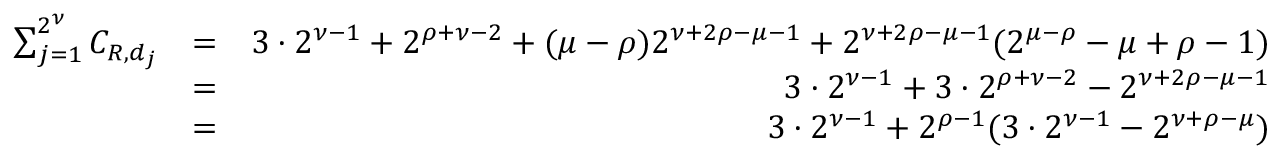Convert formula to latex. <formula><loc_0><loc_0><loc_500><loc_500>\begin{array} { r l r } { \sum _ { j = 1 } ^ { 2 ^ { \nu } } C _ { R , d _ { j } } } & { = } & { 3 \cdot 2 ^ { \nu - 1 } + 2 ^ { \rho + \nu - 2 } + ( \mu - \rho ) 2 ^ { \nu + 2 \rho - \mu - 1 } + 2 ^ { \nu + 2 \rho - \mu - 1 } ( 2 ^ { \mu - \rho } - \mu + \rho - 1 ) } \\ & { = } & { 3 \cdot 2 ^ { \nu - 1 } + 3 \cdot 2 ^ { \rho + \nu - 2 } - 2 ^ { \nu + 2 \rho - \mu - 1 } } \\ & { = } & { 3 \cdot 2 ^ { \nu - 1 } + 2 ^ { \rho - 1 } ( 3 \cdot 2 ^ { \nu - 1 } - 2 ^ { \nu + \rho - \mu } ) } \end{array}</formula> 